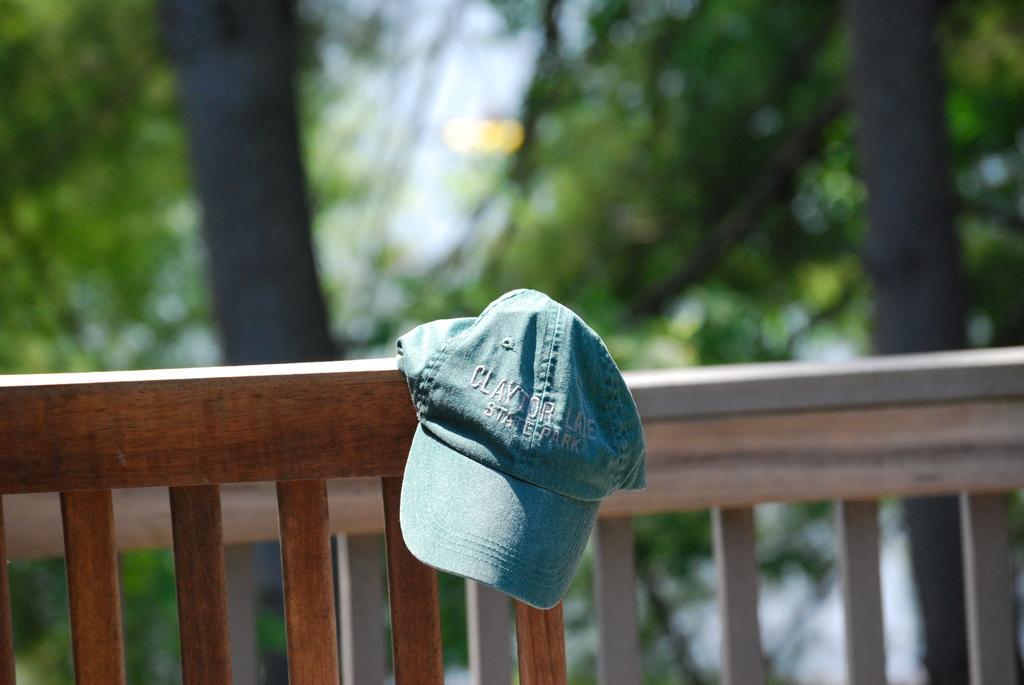Could you give a brief overview of what you see in this image? In this image I can see a brown colored wooden object on which I can see a hat which is green in color. In the background I can see the wooden railing, few trees which are green and black in color and the sky. 